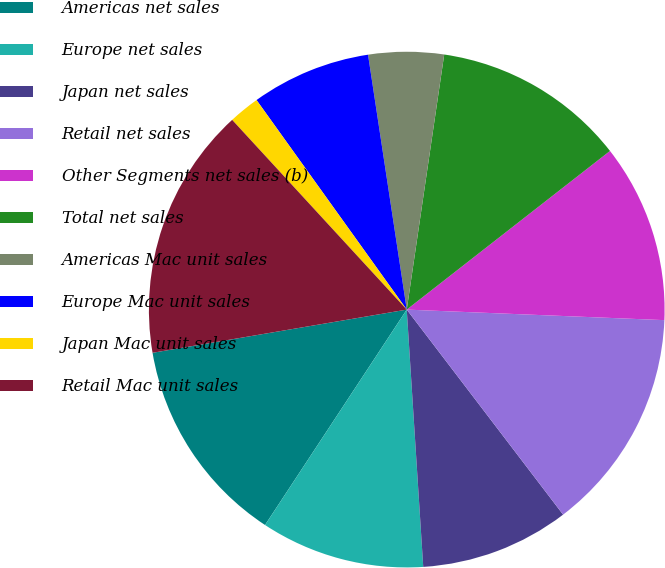Convert chart. <chart><loc_0><loc_0><loc_500><loc_500><pie_chart><fcel>Americas net sales<fcel>Europe net sales<fcel>Japan net sales<fcel>Retail net sales<fcel>Other Segments net sales (b)<fcel>Total net sales<fcel>Americas Mac unit sales<fcel>Europe Mac unit sales<fcel>Japan Mac unit sales<fcel>Retail Mac unit sales<nl><fcel>13.06%<fcel>10.28%<fcel>9.35%<fcel>13.98%<fcel>11.2%<fcel>12.13%<fcel>4.72%<fcel>7.5%<fcel>1.94%<fcel>15.84%<nl></chart> 